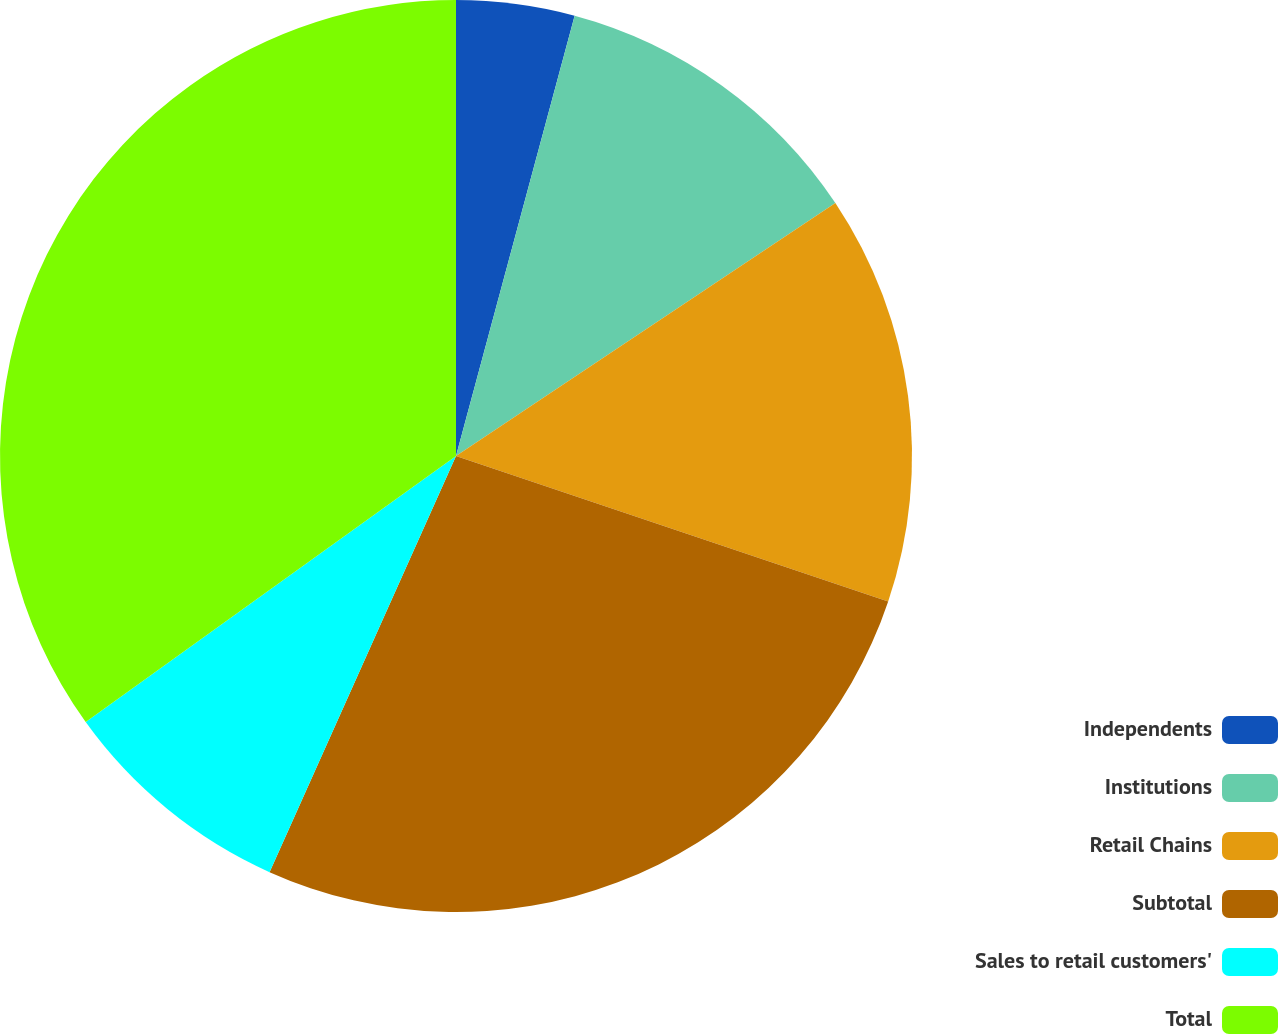<chart> <loc_0><loc_0><loc_500><loc_500><pie_chart><fcel>Independents<fcel>Institutions<fcel>Retail Chains<fcel>Subtotal<fcel>Sales to retail customers'<fcel>Total<nl><fcel>4.19%<fcel>11.45%<fcel>14.53%<fcel>26.54%<fcel>8.38%<fcel>34.92%<nl></chart> 